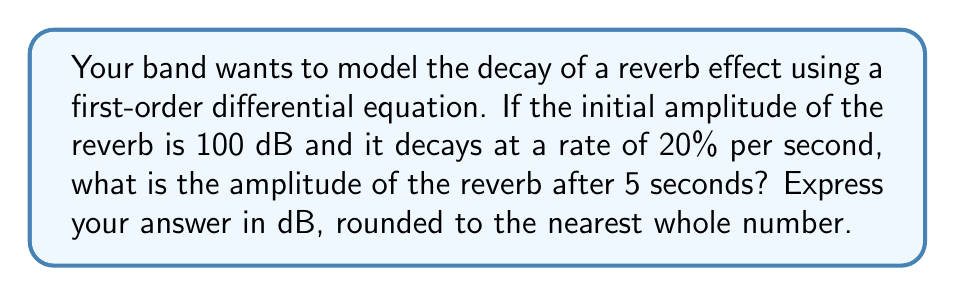Give your solution to this math problem. Let's approach this step-by-step:

1) We can model the decay of the reverb using the first-order differential equation:

   $$\frac{dA}{dt} = -kA$$

   where $A$ is the amplitude, $t$ is time, and $k$ is the decay constant.

2) Given that the decay rate is 20% per second, we can determine $k$:

   $$k = 0.20$$

3) The solution to this differential equation is:

   $$A(t) = A_0e^{-kt}$$

   where $A_0$ is the initial amplitude.

4) We're given:
   $A_0 = 100$ dB
   $k = 0.20$
   $t = 5$ seconds

5) Plugging these values into our equation:

   $$A(5) = 100e^{-0.20 \cdot 5}$$

6) Let's calculate:

   $$A(5) = 100e^{-1} \approx 36.79$$

7) Rounding to the nearest whole number:

   $$A(5) \approx 37$$ dB
Answer: 37 dB 